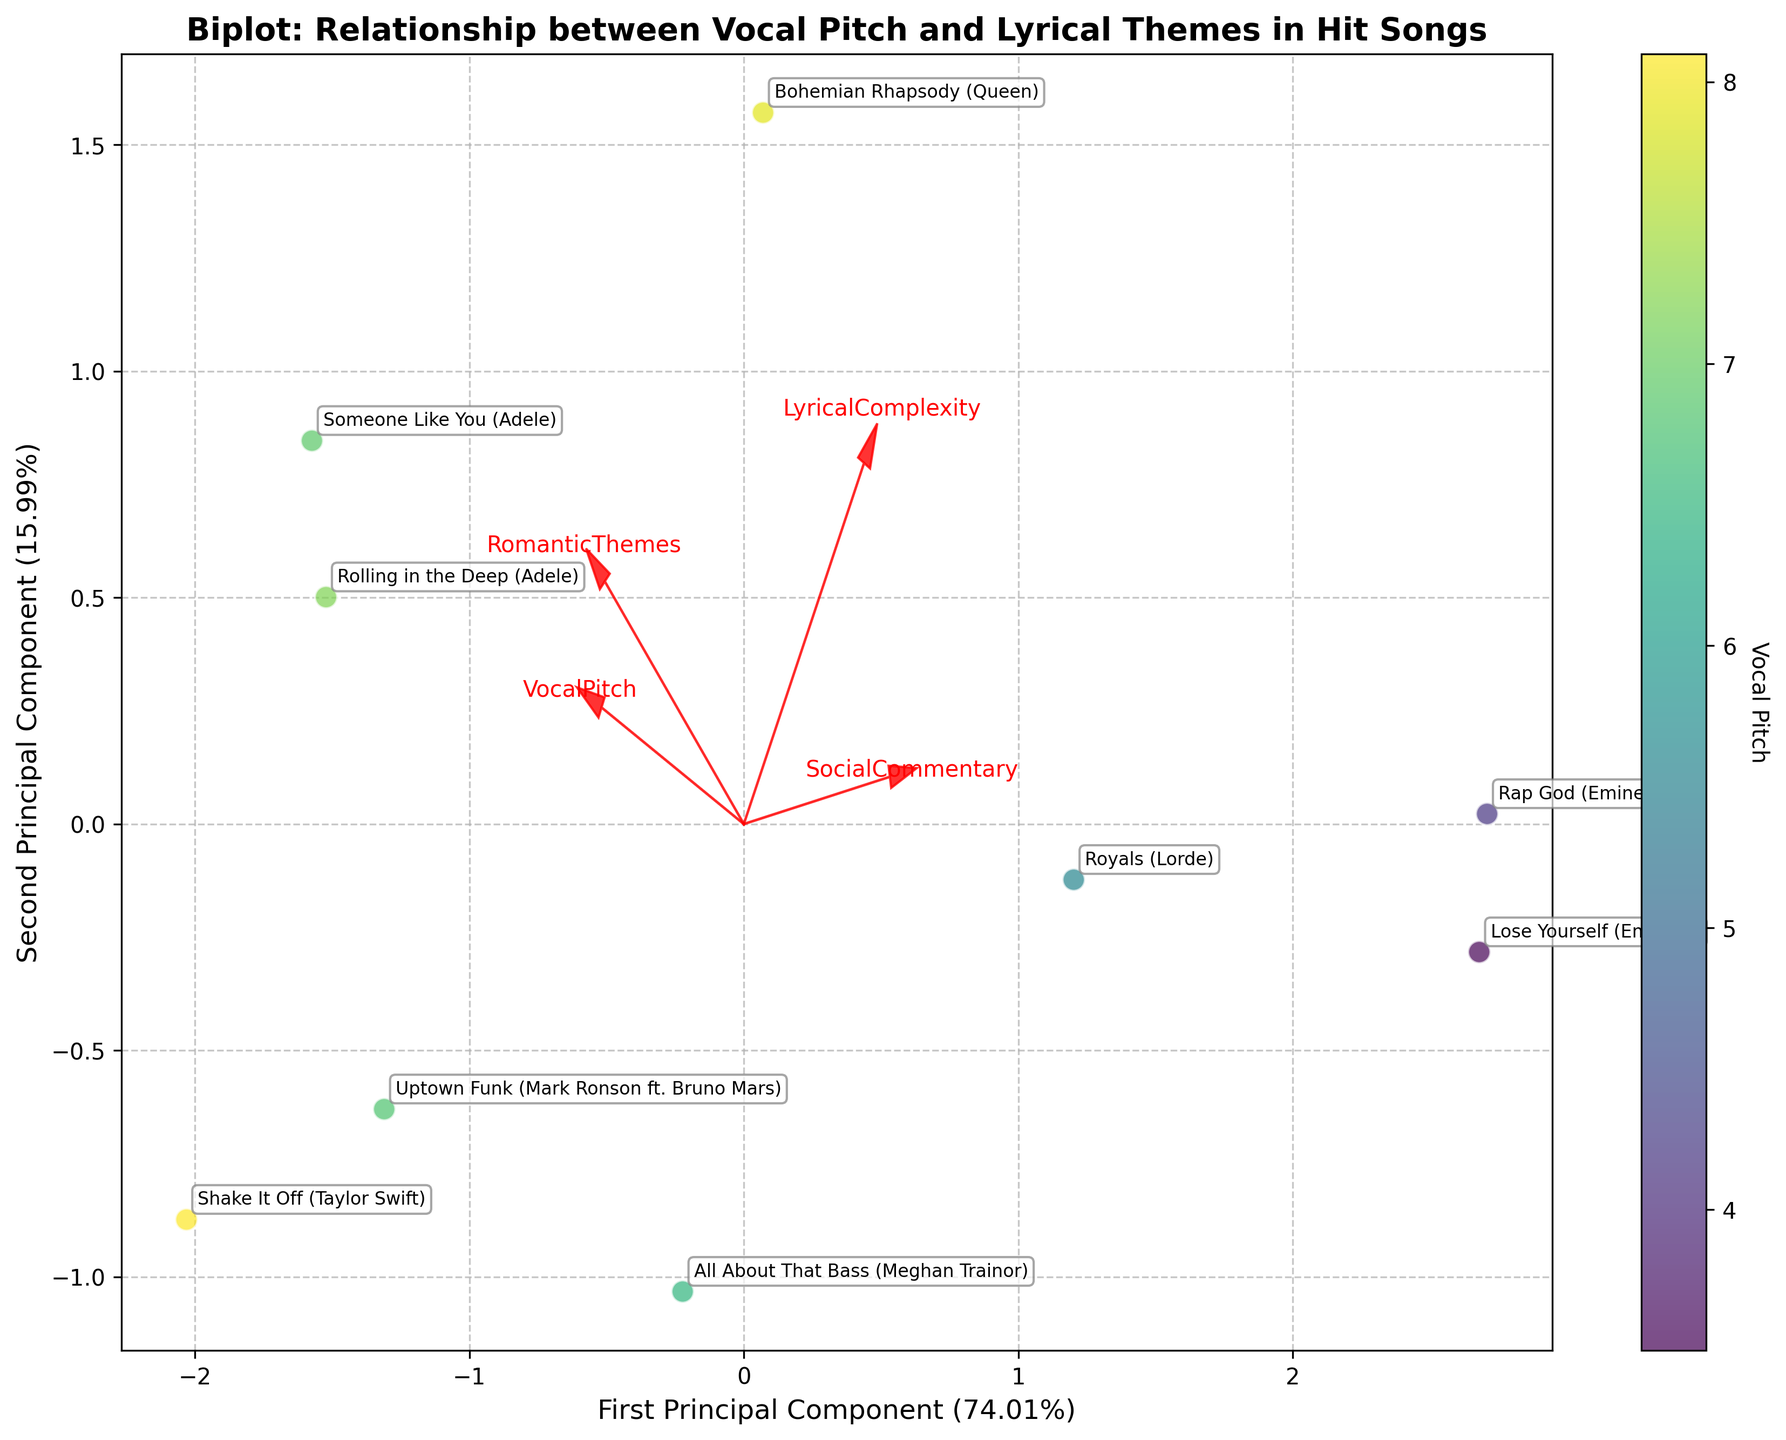What is the title of the figure? The title is displayed at the top of the plot. It provides a brief description of the figure's content.
Answer: Biplot: Relationship between Vocal Pitch and Lyrical Themes in Hit Songs How many songs are represented in the biplot? Count the number of distinct labels or points on the plot, each representing a song.
Answer: 9 Which song has the highest vocal pitch in the biplot? Locate the point on the plot that correlates with the highest color intensity based on the colorbar representing vocal pitch.
Answer: "Shake It Off" (Taylor Swift) What is the first principal component's explained variance percentage? The percentage is displayed on the x-axis label. Read the exact value.
Answer: 44.15% How does "Rap God" (Eminem) relate to Social Commentary in the biplot? Find the vector labeled 'SocialCommentary' and see if "Rap God" (Eminem) is oriented in the same direction, indicating a strong relation.
Answer: Strong positive relationship Which song displays a high lyrical complexity but a low romantic theme? Look for the point near the vector 'LyricalComplexity' but further from 'RomanticThemes'.
Answer: "Rap God" (Eminem) What is the range of the second principal component? Observe the numerical range on the y-axis (Second Principal Component) from the lowest to the highest tick mark.
Answer: Approximately -2 to 2 Which songs are near the 'RomanticThemes' vector but away from 'SocialCommentary'? Identify the points close to the 'RomanticThemes' vector and relatively far from 'SocialCommentary'.
Answer: "Someone Like You" (Adele), "Rolling in the Deep" (Adele) What commonality can be derived among the songs "Royals" (Lorde) and "Lose Yourself" (Eminem) based on the biplot? Locate both points on the plot; if they are close and oriented similarly, they share common features, likely related to social commentary.
Answer: High Social Commentary Compare the placement of "Bohemian Rhapsody" (Queen) with "Uptown Funk" (Mark Ronson ft. Bruno Mars) in terms of principal components. Determine their relative positions on the principal component axes to see how they differ.
Answer: "Bohemian Rhapsody" is higher on the second component and to the left; "Uptown Funk" is more centered 